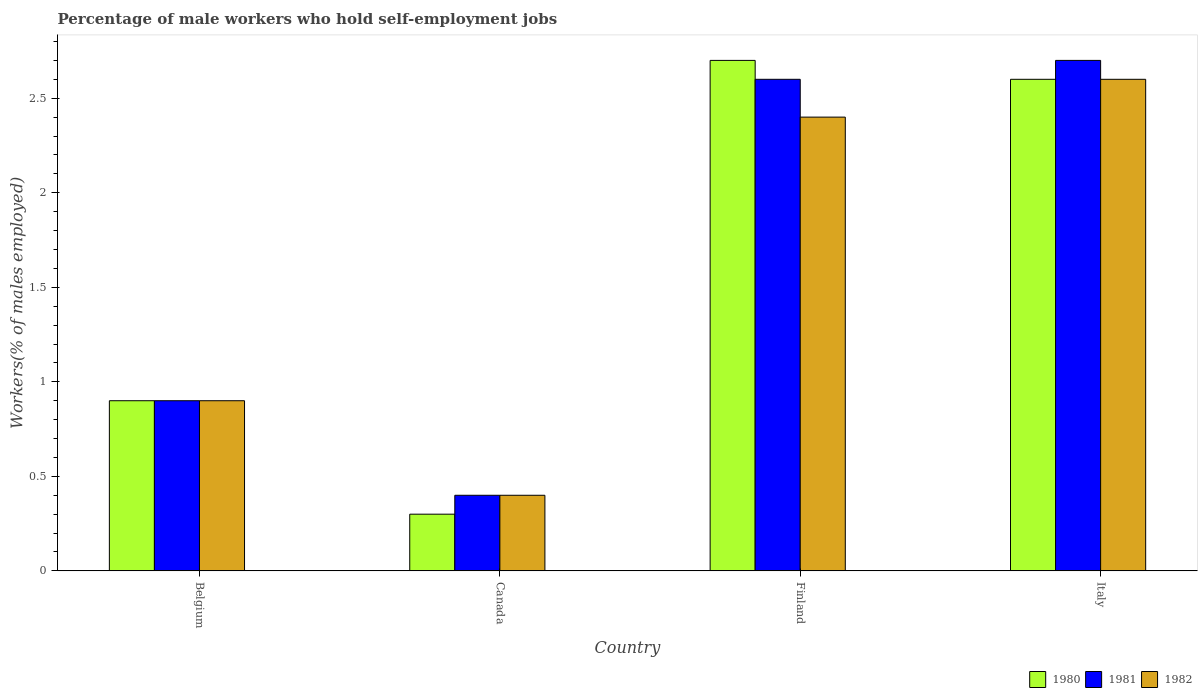How many different coloured bars are there?
Provide a short and direct response. 3. How many bars are there on the 3rd tick from the right?
Your answer should be very brief. 3. What is the label of the 2nd group of bars from the left?
Offer a very short reply. Canada. What is the percentage of self-employed male workers in 1980 in Italy?
Offer a very short reply. 2.6. Across all countries, what is the maximum percentage of self-employed male workers in 1981?
Give a very brief answer. 2.7. Across all countries, what is the minimum percentage of self-employed male workers in 1981?
Make the answer very short. 0.4. In which country was the percentage of self-employed male workers in 1981 minimum?
Keep it short and to the point. Canada. What is the total percentage of self-employed male workers in 1980 in the graph?
Offer a terse response. 6.5. What is the difference between the percentage of self-employed male workers in 1982 in Belgium and that in Italy?
Your answer should be compact. -1.7. What is the difference between the percentage of self-employed male workers in 1982 in Italy and the percentage of self-employed male workers in 1981 in Belgium?
Provide a succinct answer. 1.7. What is the average percentage of self-employed male workers in 1980 per country?
Provide a succinct answer. 1.62. What is the ratio of the percentage of self-employed male workers in 1982 in Canada to that in Finland?
Your response must be concise. 0.17. Is the percentage of self-employed male workers in 1981 in Finland less than that in Italy?
Provide a succinct answer. Yes. Is the difference between the percentage of self-employed male workers in 1980 in Canada and Italy greater than the difference between the percentage of self-employed male workers in 1981 in Canada and Italy?
Provide a succinct answer. Yes. What is the difference between the highest and the second highest percentage of self-employed male workers in 1982?
Provide a short and direct response. -1.7. What is the difference between the highest and the lowest percentage of self-employed male workers in 1981?
Your answer should be compact. 2.3. In how many countries, is the percentage of self-employed male workers in 1982 greater than the average percentage of self-employed male workers in 1982 taken over all countries?
Offer a very short reply. 2. Is the sum of the percentage of self-employed male workers in 1982 in Canada and Italy greater than the maximum percentage of self-employed male workers in 1981 across all countries?
Make the answer very short. Yes. What does the 1st bar from the right in Finland represents?
Provide a succinct answer. 1982. Is it the case that in every country, the sum of the percentage of self-employed male workers in 1980 and percentage of self-employed male workers in 1981 is greater than the percentage of self-employed male workers in 1982?
Make the answer very short. Yes. What is the difference between two consecutive major ticks on the Y-axis?
Offer a terse response. 0.5. Does the graph contain any zero values?
Your answer should be very brief. No. Where does the legend appear in the graph?
Offer a terse response. Bottom right. What is the title of the graph?
Ensure brevity in your answer.  Percentage of male workers who hold self-employment jobs. Does "1995" appear as one of the legend labels in the graph?
Give a very brief answer. No. What is the label or title of the Y-axis?
Your response must be concise. Workers(% of males employed). What is the Workers(% of males employed) of 1980 in Belgium?
Keep it short and to the point. 0.9. What is the Workers(% of males employed) of 1981 in Belgium?
Offer a very short reply. 0.9. What is the Workers(% of males employed) in 1982 in Belgium?
Offer a terse response. 0.9. What is the Workers(% of males employed) in 1980 in Canada?
Offer a very short reply. 0.3. What is the Workers(% of males employed) in 1981 in Canada?
Your response must be concise. 0.4. What is the Workers(% of males employed) of 1982 in Canada?
Your answer should be compact. 0.4. What is the Workers(% of males employed) in 1980 in Finland?
Your answer should be compact. 2.7. What is the Workers(% of males employed) of 1981 in Finland?
Your response must be concise. 2.6. What is the Workers(% of males employed) of 1982 in Finland?
Your response must be concise. 2.4. What is the Workers(% of males employed) of 1980 in Italy?
Provide a short and direct response. 2.6. What is the Workers(% of males employed) of 1981 in Italy?
Your answer should be very brief. 2.7. What is the Workers(% of males employed) of 1982 in Italy?
Offer a very short reply. 2.6. Across all countries, what is the maximum Workers(% of males employed) of 1980?
Provide a short and direct response. 2.7. Across all countries, what is the maximum Workers(% of males employed) in 1981?
Offer a terse response. 2.7. Across all countries, what is the maximum Workers(% of males employed) of 1982?
Your answer should be very brief. 2.6. Across all countries, what is the minimum Workers(% of males employed) in 1980?
Keep it short and to the point. 0.3. Across all countries, what is the minimum Workers(% of males employed) of 1981?
Your answer should be compact. 0.4. Across all countries, what is the minimum Workers(% of males employed) of 1982?
Make the answer very short. 0.4. What is the total Workers(% of males employed) in 1981 in the graph?
Your answer should be very brief. 6.6. What is the difference between the Workers(% of males employed) of 1981 in Belgium and that in Canada?
Keep it short and to the point. 0.5. What is the difference between the Workers(% of males employed) in 1982 in Belgium and that in Canada?
Your answer should be very brief. 0.5. What is the difference between the Workers(% of males employed) of 1980 in Belgium and that in Finland?
Give a very brief answer. -1.8. What is the difference between the Workers(% of males employed) in 1982 in Belgium and that in Finland?
Give a very brief answer. -1.5. What is the difference between the Workers(% of males employed) of 1980 in Belgium and that in Italy?
Offer a very short reply. -1.7. What is the difference between the Workers(% of males employed) of 1981 in Belgium and that in Italy?
Your response must be concise. -1.8. What is the difference between the Workers(% of males employed) in 1982 in Belgium and that in Italy?
Offer a terse response. -1.7. What is the difference between the Workers(% of males employed) of 1982 in Canada and that in Finland?
Offer a terse response. -2. What is the difference between the Workers(% of males employed) in 1982 in Canada and that in Italy?
Your answer should be very brief. -2.2. What is the difference between the Workers(% of males employed) in 1982 in Finland and that in Italy?
Make the answer very short. -0.2. What is the difference between the Workers(% of males employed) of 1980 in Belgium and the Workers(% of males employed) of 1981 in Canada?
Make the answer very short. 0.5. What is the difference between the Workers(% of males employed) in 1980 in Belgium and the Workers(% of males employed) in 1982 in Canada?
Your answer should be compact. 0.5. What is the difference between the Workers(% of males employed) of 1980 in Belgium and the Workers(% of males employed) of 1981 in Finland?
Offer a very short reply. -1.7. What is the difference between the Workers(% of males employed) of 1980 in Belgium and the Workers(% of males employed) of 1982 in Finland?
Your answer should be compact. -1.5. What is the difference between the Workers(% of males employed) in 1981 in Belgium and the Workers(% of males employed) in 1982 in Finland?
Ensure brevity in your answer.  -1.5. What is the difference between the Workers(% of males employed) of 1980 in Belgium and the Workers(% of males employed) of 1981 in Italy?
Your answer should be very brief. -1.8. What is the difference between the Workers(% of males employed) of 1980 in Canada and the Workers(% of males employed) of 1981 in Finland?
Make the answer very short. -2.3. What is the difference between the Workers(% of males employed) in 1980 in Canada and the Workers(% of males employed) in 1982 in Finland?
Make the answer very short. -2.1. What is the difference between the Workers(% of males employed) in 1981 in Canada and the Workers(% of males employed) in 1982 in Finland?
Keep it short and to the point. -2. What is the difference between the Workers(% of males employed) of 1980 in Canada and the Workers(% of males employed) of 1981 in Italy?
Provide a short and direct response. -2.4. What is the difference between the Workers(% of males employed) of 1980 in Canada and the Workers(% of males employed) of 1982 in Italy?
Ensure brevity in your answer.  -2.3. What is the difference between the Workers(% of males employed) of 1980 in Finland and the Workers(% of males employed) of 1981 in Italy?
Your response must be concise. 0. What is the difference between the Workers(% of males employed) in 1981 in Finland and the Workers(% of males employed) in 1982 in Italy?
Provide a succinct answer. 0. What is the average Workers(% of males employed) in 1980 per country?
Provide a short and direct response. 1.62. What is the average Workers(% of males employed) of 1981 per country?
Your response must be concise. 1.65. What is the average Workers(% of males employed) of 1982 per country?
Your response must be concise. 1.57. What is the difference between the Workers(% of males employed) in 1980 and Workers(% of males employed) in 1981 in Belgium?
Offer a terse response. 0. What is the difference between the Workers(% of males employed) in 1980 and Workers(% of males employed) in 1981 in Canada?
Keep it short and to the point. -0.1. What is the difference between the Workers(% of males employed) of 1980 and Workers(% of males employed) of 1982 in Canada?
Your response must be concise. -0.1. What is the difference between the Workers(% of males employed) of 1980 and Workers(% of males employed) of 1981 in Finland?
Provide a short and direct response. 0.1. What is the difference between the Workers(% of males employed) of 1980 and Workers(% of males employed) of 1982 in Italy?
Ensure brevity in your answer.  0. What is the ratio of the Workers(% of males employed) in 1980 in Belgium to that in Canada?
Your answer should be compact. 3. What is the ratio of the Workers(% of males employed) of 1981 in Belgium to that in Canada?
Offer a terse response. 2.25. What is the ratio of the Workers(% of males employed) in 1982 in Belgium to that in Canada?
Offer a very short reply. 2.25. What is the ratio of the Workers(% of males employed) of 1981 in Belgium to that in Finland?
Your answer should be very brief. 0.35. What is the ratio of the Workers(% of males employed) in 1982 in Belgium to that in Finland?
Give a very brief answer. 0.38. What is the ratio of the Workers(% of males employed) in 1980 in Belgium to that in Italy?
Your answer should be compact. 0.35. What is the ratio of the Workers(% of males employed) in 1982 in Belgium to that in Italy?
Provide a short and direct response. 0.35. What is the ratio of the Workers(% of males employed) in 1980 in Canada to that in Finland?
Give a very brief answer. 0.11. What is the ratio of the Workers(% of males employed) in 1981 in Canada to that in Finland?
Make the answer very short. 0.15. What is the ratio of the Workers(% of males employed) in 1980 in Canada to that in Italy?
Provide a succinct answer. 0.12. What is the ratio of the Workers(% of males employed) in 1981 in Canada to that in Italy?
Keep it short and to the point. 0.15. What is the ratio of the Workers(% of males employed) in 1982 in Canada to that in Italy?
Provide a succinct answer. 0.15. What is the ratio of the Workers(% of males employed) in 1980 in Finland to that in Italy?
Give a very brief answer. 1.04. What is the ratio of the Workers(% of males employed) in 1982 in Finland to that in Italy?
Give a very brief answer. 0.92. What is the difference between the highest and the second highest Workers(% of males employed) of 1981?
Give a very brief answer. 0.1. 